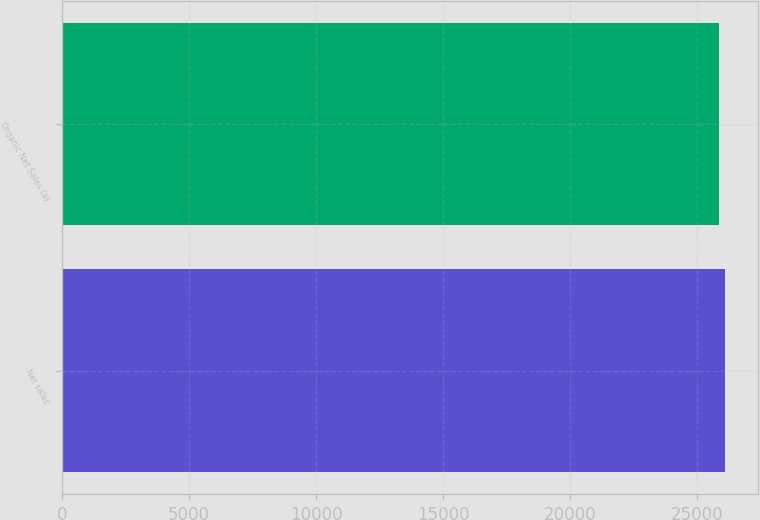Convert chart. <chart><loc_0><loc_0><loc_500><loc_500><bar_chart><fcel>Net sales<fcel>Organic Net Sales (a)<nl><fcel>26076<fcel>25876<nl></chart> 